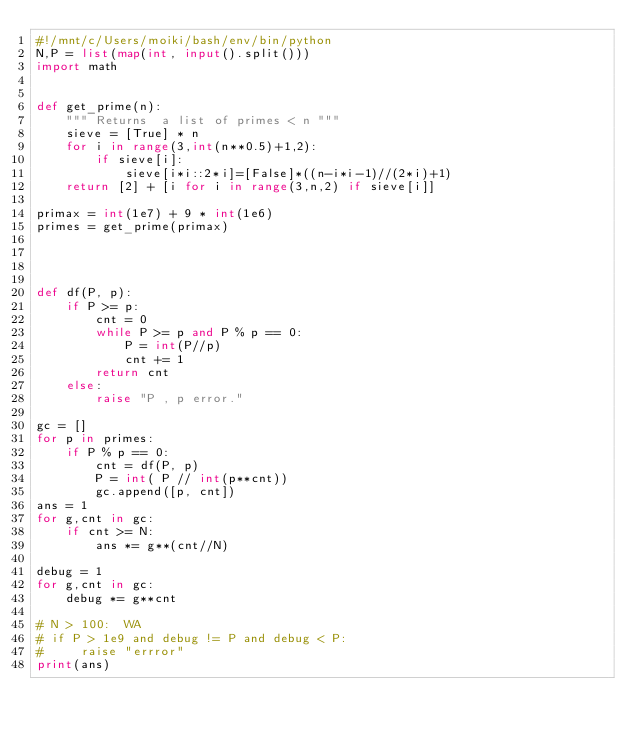<code> <loc_0><loc_0><loc_500><loc_500><_Python_>#!/mnt/c/Users/moiki/bash/env/bin/python
N,P = list(map(int, input().split()))
import math


def get_prime(n):
    """ Returns  a list of primes < n """
    sieve = [True] * n
    for i in range(3,int(n**0.5)+1,2):
        if sieve[i]:
            sieve[i*i::2*i]=[False]*((n-i*i-1)//(2*i)+1)
    return [2] + [i for i in range(3,n,2) if sieve[i]]

primax = int(1e7) + 9 * int(1e6)
primes = get_prime(primax)




def df(P, p):
    if P >= p:
        cnt = 0
        while P >= p and P % p == 0:
            P = int(P//p)
            cnt += 1
        return cnt
    else:
        raise "P , p error."

gc = []
for p in primes:
    if P % p == 0:
        cnt = df(P, p)
        P = int( P // int(p**cnt))
        gc.append([p, cnt])
ans = 1
for g,cnt in gc:
    if cnt >= N:
        ans *= g**(cnt//N)

debug = 1
for g,cnt in gc:
    debug *= g**cnt

# N > 100:  WA
# if P > 1e9 and debug != P and debug < P:
#     raise "errror"
print(ans)
</code> 